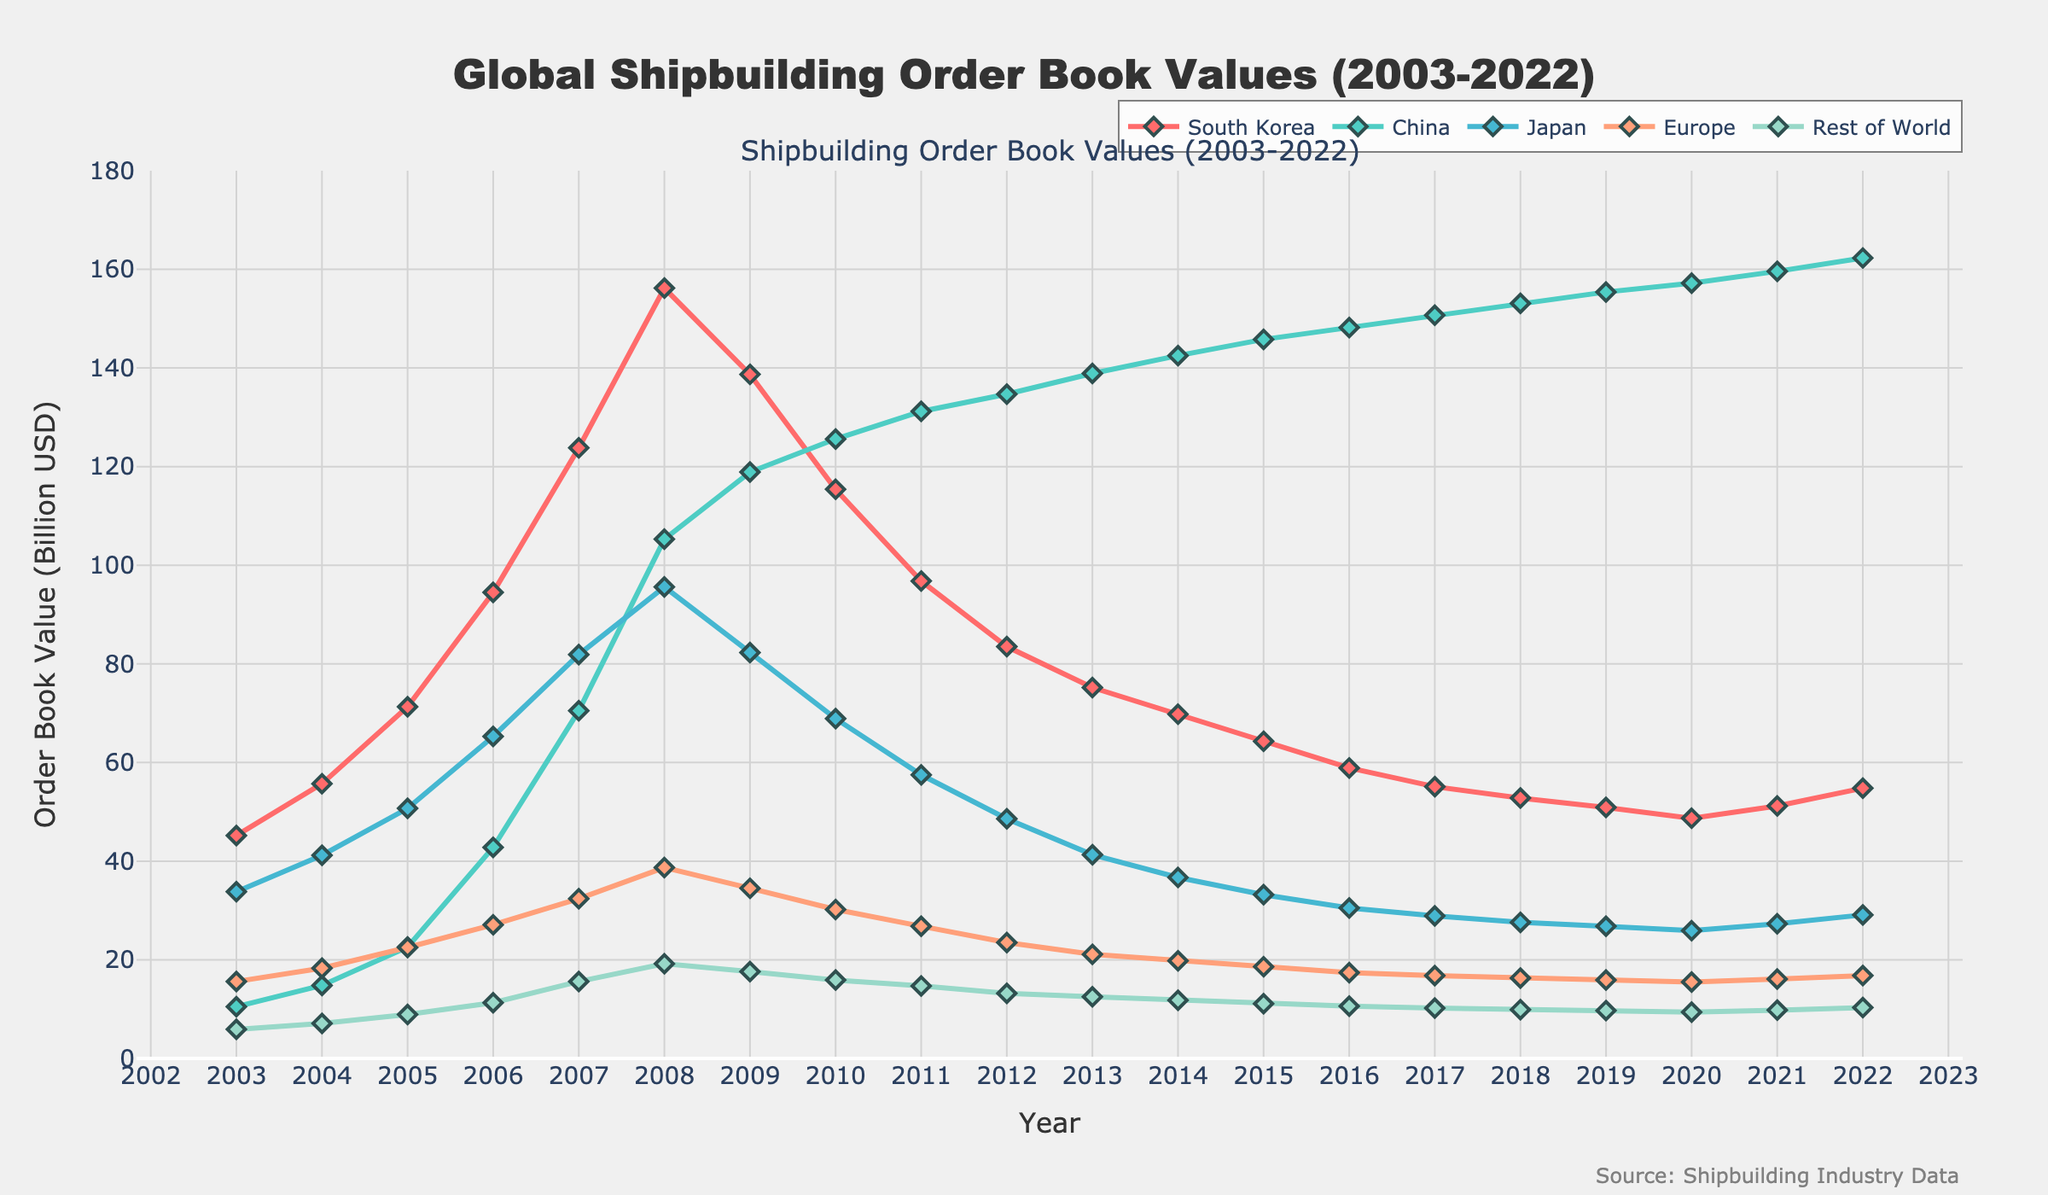What country had the highest shipbuilding order book value in 2022? Look at the end of each plotted line in the figure for the year 2022. China has the highest value among all countries.
Answer: China Which year did South Korea have its peak in shipbuilding order book values? Trace the line representing South Korea over the years and find the highest point, which occurs in 2008.
Answer: 2008 How does the order book value of Japan in 2010 compare to its value in 2020? Find the values on the line representing Japan for the years 2010 and 2020. The values are 68.9 and 25.9, respectively. The value in 2010 is higher than in 2020.
Answer: The value in 2010 is higher What is the combined order book value of China and Japan in 2011? Take the values of China (131.2) and Japan (57.5) in 2011, and sum them up, which gives 131.2 + 57.5 = 188.7.
Answer: 188.7 Which region showed a consistent increase in order book values from 2003 to 2022? Examine the lines for each region. China's line consistently trends upwards throughout all the years from 2003 to 2022.
Answer: China In which year did Europe surpass the Rest of World in order book value? Compare the lines for Europe and Rest of World year by year. In 2006, Europe surpassed Rest of World with values of 27.1 and 11.3, respectively.
Answer: 2006 Between 2007 and 2008, which country showed the largest increase in shipbuilding order book value? Calculate the difference between the values of 2007 and 2008 for each country: South Korea (156.2 - 123.8 = 32.4), China (105.3 - 70.5 = 34.8), Japan (95.6 - 81.9 = 13.7), Europe (38.7 - 32.4 = 6.3), Rest of World (19.2 - 15.6 = 3.6). China shows the largest increase.
Answer: China Which country's order book value decreased the most from its peak to 2022? Identify the peak values for each country and compare them to their 2022 values: South Korea (156.2 - 54.8 = 101.4), China (162.3 - 10.5 = 0), Japan (95.6 - 29.1 = 66.5), Europe (38.7 - 16.8 = 21.9), Rest of World (19.2 - 10.3 = 8.9). South Korea has the largest decrease.
Answer: South Korea If you sum up the order book values for all regions in 2010, what do you get? Add values for all the regions in 2010: 115.4 (South Korea) + 125.6 (China) + 68.9 (Japan) + 30.2 (Europe) + 15.9 (Rest of World) = 356.0.
Answer: 356.0 What trend can be observed for Europe's order book values from 2003 to 2022? Observe the trajectory of the line representing Europe from beginning to end. It shows a gradual but consistent decline over the years.
Answer: Declining trend 